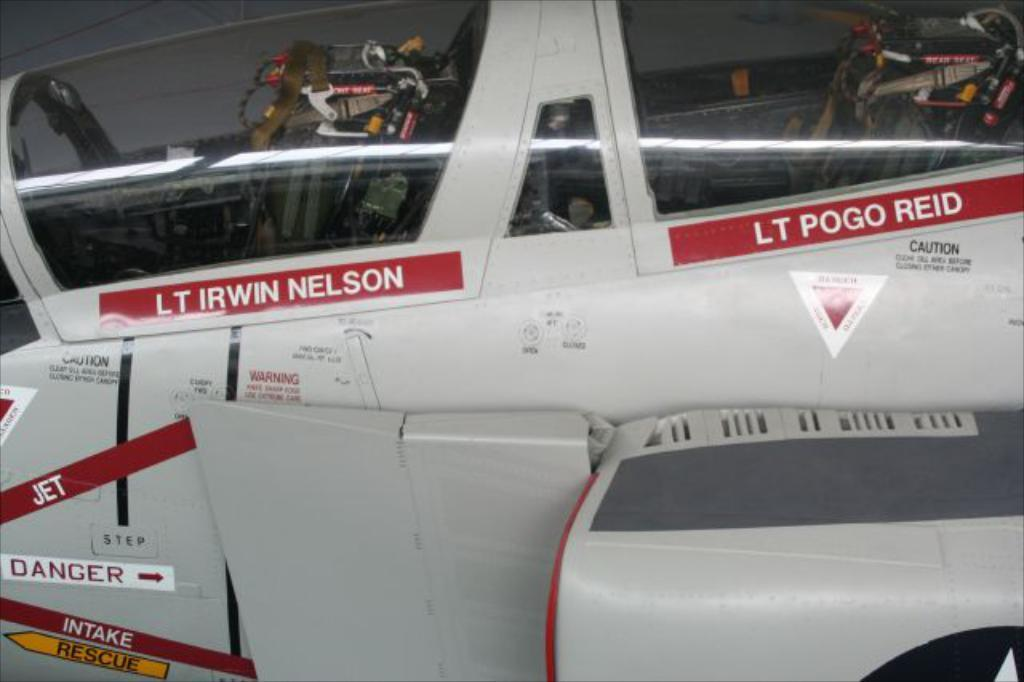<image>
Write a terse but informative summary of the picture. a jet with the name LT pogo Reid for the co pilot 